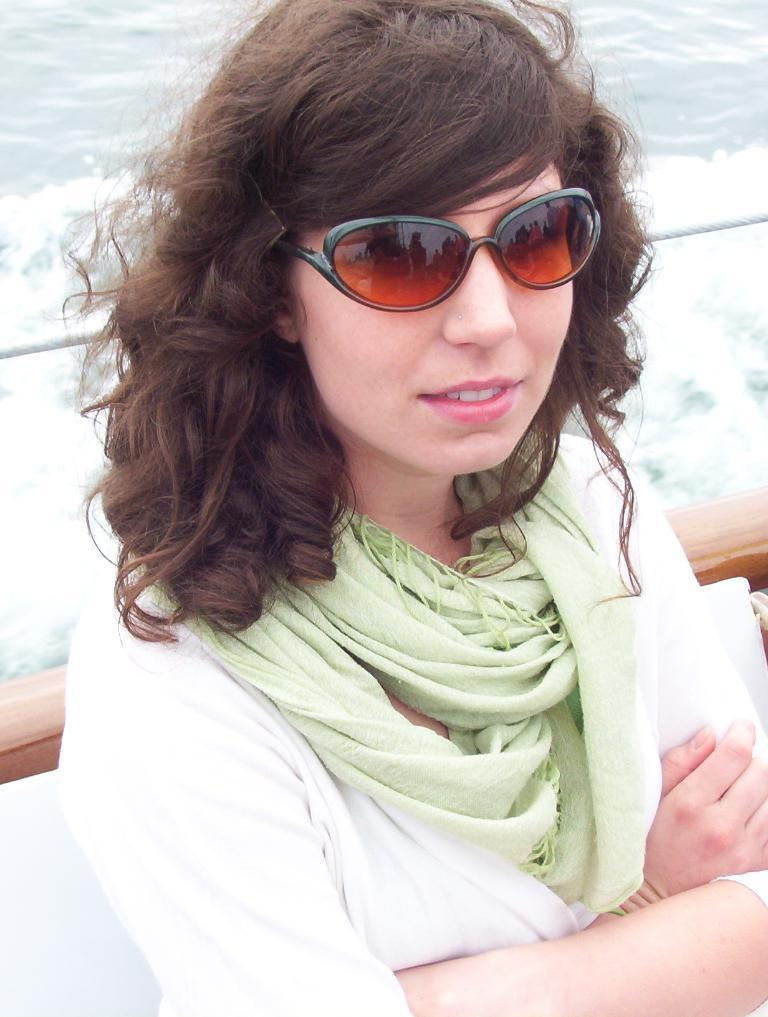Who is present in the image? There is a woman in the image. What is the woman wearing on her face? The woman is wearing goggles. What can be seen in the background of the image? There is water visible in the background of the image. What type of roof can be seen on the airport in the image? There is no airport or roof present in the image; it features a woman wearing goggles. 